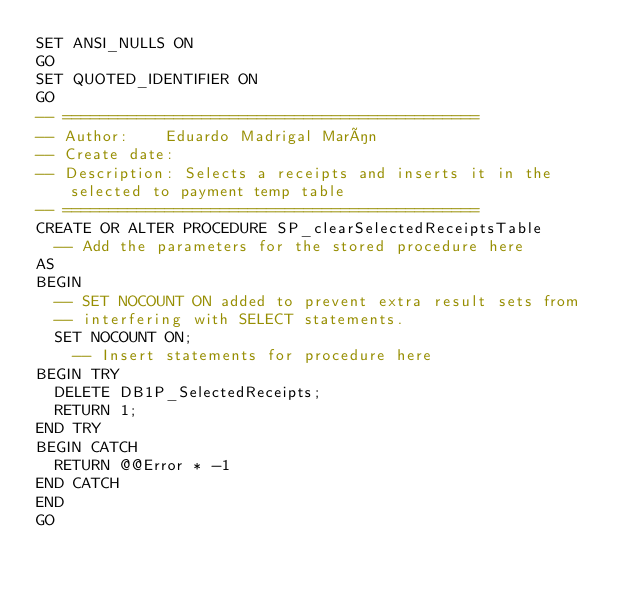<code> <loc_0><loc_0><loc_500><loc_500><_SQL_>SET ANSI_NULLS ON
GO
SET QUOTED_IDENTIFIER ON
GO
-- =============================================
-- Author:		Eduardo Madrigal Marín
-- Create date: 
-- Description:	Selects a receipts and inserts it in the selected to payment temp table
-- =============================================
CREATE OR ALTER PROCEDURE SP_clearSelectedReceiptsTable
	-- Add the parameters for the stored procedure here
AS
BEGIN
	-- SET NOCOUNT ON added to prevent extra result sets from
	-- interfering with SELECT statements.
	SET NOCOUNT ON;
    -- Insert statements for procedure here
BEGIN TRY
	DELETE DB1P_SelectedReceipts;
	RETURN 1;
END TRY
BEGIN CATCH
	RETURN @@Error * -1
END CATCH
END
GO</code> 